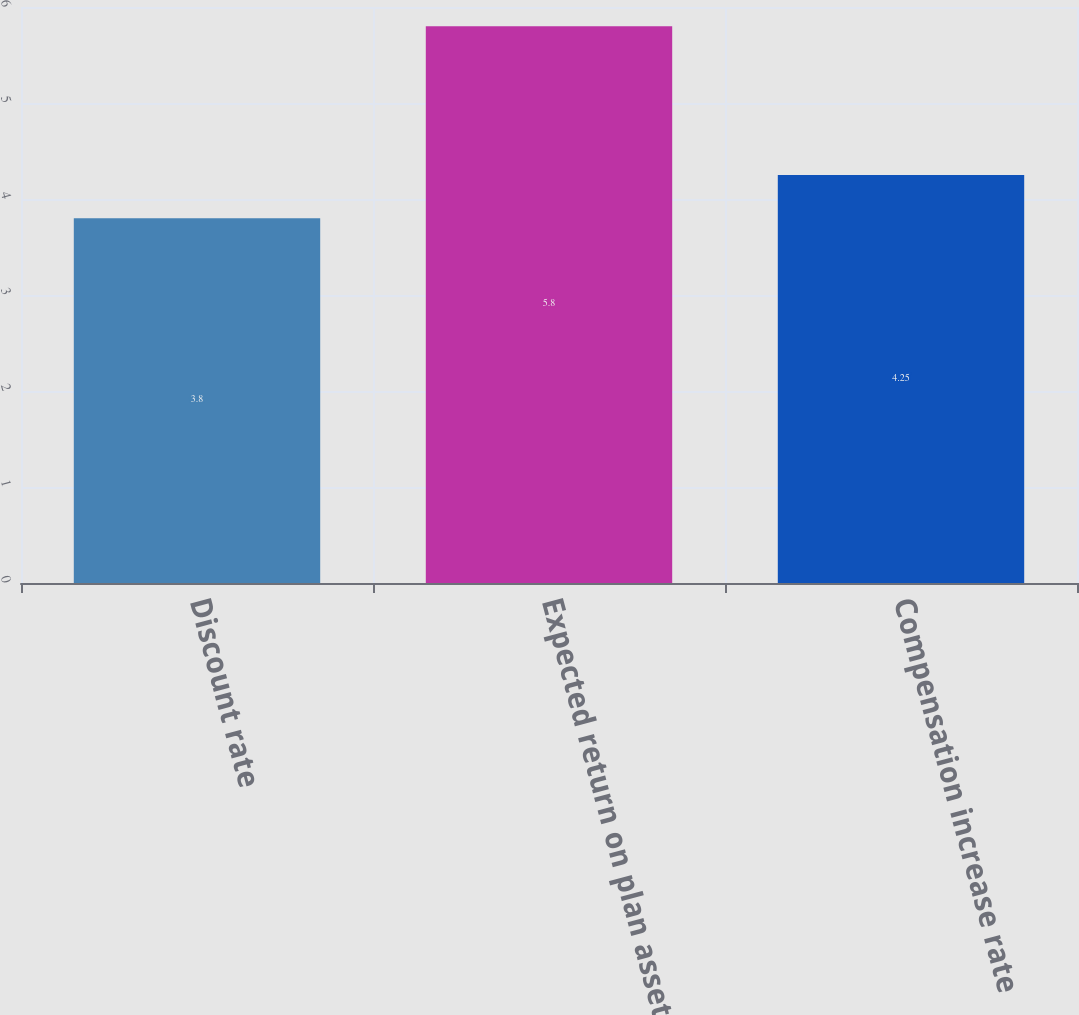Convert chart. <chart><loc_0><loc_0><loc_500><loc_500><bar_chart><fcel>Discount rate<fcel>Expected return on plan assets<fcel>Compensation increase rate<nl><fcel>3.8<fcel>5.8<fcel>4.25<nl></chart> 